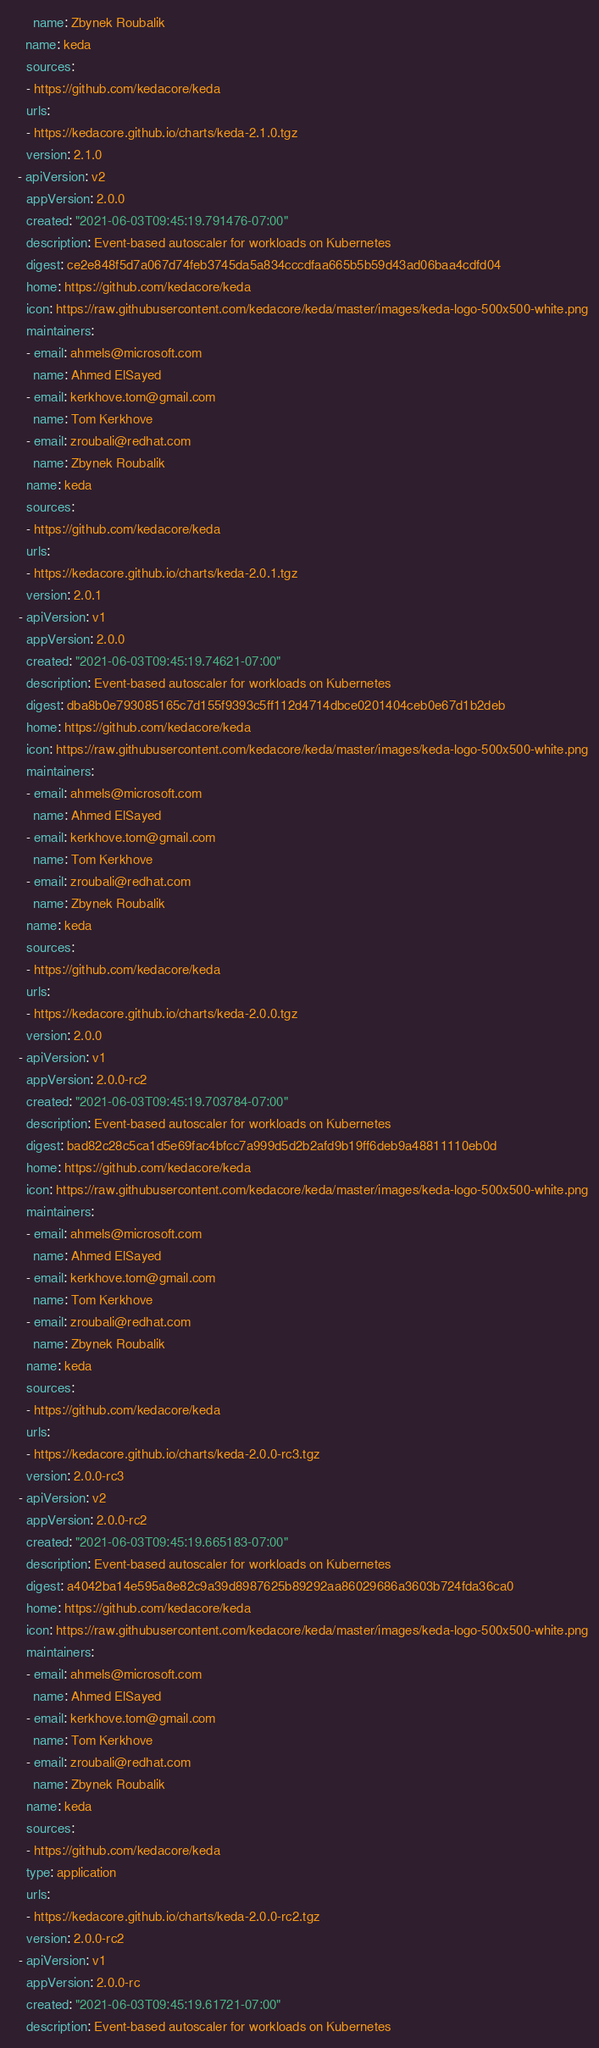Convert code to text. <code><loc_0><loc_0><loc_500><loc_500><_YAML_>      name: Zbynek Roubalik
    name: keda
    sources:
    - https://github.com/kedacore/keda
    urls:
    - https://kedacore.github.io/charts/keda-2.1.0.tgz
    version: 2.1.0
  - apiVersion: v2
    appVersion: 2.0.0
    created: "2021-06-03T09:45:19.791476-07:00"
    description: Event-based autoscaler for workloads on Kubernetes
    digest: ce2e848f5d7a067d74feb3745da5a834cccdfaa665b5b59d43ad06baa4cdfd04
    home: https://github.com/kedacore/keda
    icon: https://raw.githubusercontent.com/kedacore/keda/master/images/keda-logo-500x500-white.png
    maintainers:
    - email: ahmels@microsoft.com
      name: Ahmed ElSayed
    - email: kerkhove.tom@gmail.com
      name: Tom Kerkhove
    - email: zroubali@redhat.com
      name: Zbynek Roubalik
    name: keda
    sources:
    - https://github.com/kedacore/keda
    urls:
    - https://kedacore.github.io/charts/keda-2.0.1.tgz
    version: 2.0.1
  - apiVersion: v1
    appVersion: 2.0.0
    created: "2021-06-03T09:45:19.74621-07:00"
    description: Event-based autoscaler for workloads on Kubernetes
    digest: dba8b0e793085165c7d155f9393c5ff112d4714dbce0201404ceb0e67d1b2deb
    home: https://github.com/kedacore/keda
    icon: https://raw.githubusercontent.com/kedacore/keda/master/images/keda-logo-500x500-white.png
    maintainers:
    - email: ahmels@microsoft.com
      name: Ahmed ElSayed
    - email: kerkhove.tom@gmail.com
      name: Tom Kerkhove
    - email: zroubali@redhat.com
      name: Zbynek Roubalik
    name: keda
    sources:
    - https://github.com/kedacore/keda
    urls:
    - https://kedacore.github.io/charts/keda-2.0.0.tgz
    version: 2.0.0
  - apiVersion: v1
    appVersion: 2.0.0-rc2
    created: "2021-06-03T09:45:19.703784-07:00"
    description: Event-based autoscaler for workloads on Kubernetes
    digest: bad82c28c5ca1d5e69fac4bfcc7a999d5d2b2afd9b19ff6deb9a48811110eb0d
    home: https://github.com/kedacore/keda
    icon: https://raw.githubusercontent.com/kedacore/keda/master/images/keda-logo-500x500-white.png
    maintainers:
    - email: ahmels@microsoft.com
      name: Ahmed ElSayed
    - email: kerkhove.tom@gmail.com
      name: Tom Kerkhove
    - email: zroubali@redhat.com
      name: Zbynek Roubalik
    name: keda
    sources:
    - https://github.com/kedacore/keda
    urls:
    - https://kedacore.github.io/charts/keda-2.0.0-rc3.tgz
    version: 2.0.0-rc3
  - apiVersion: v2
    appVersion: 2.0.0-rc2
    created: "2021-06-03T09:45:19.665183-07:00"
    description: Event-based autoscaler for workloads on Kubernetes
    digest: a4042ba14e595a8e82c9a39d8987625b89292aa86029686a3603b724fda36ca0
    home: https://github.com/kedacore/keda
    icon: https://raw.githubusercontent.com/kedacore/keda/master/images/keda-logo-500x500-white.png
    maintainers:
    - email: ahmels@microsoft.com
      name: Ahmed ElSayed
    - email: kerkhove.tom@gmail.com
      name: Tom Kerkhove
    - email: zroubali@redhat.com
      name: Zbynek Roubalik
    name: keda
    sources:
    - https://github.com/kedacore/keda
    type: application
    urls:
    - https://kedacore.github.io/charts/keda-2.0.0-rc2.tgz
    version: 2.0.0-rc2
  - apiVersion: v1
    appVersion: 2.0.0-rc
    created: "2021-06-03T09:45:19.61721-07:00"
    description: Event-based autoscaler for workloads on Kubernetes</code> 